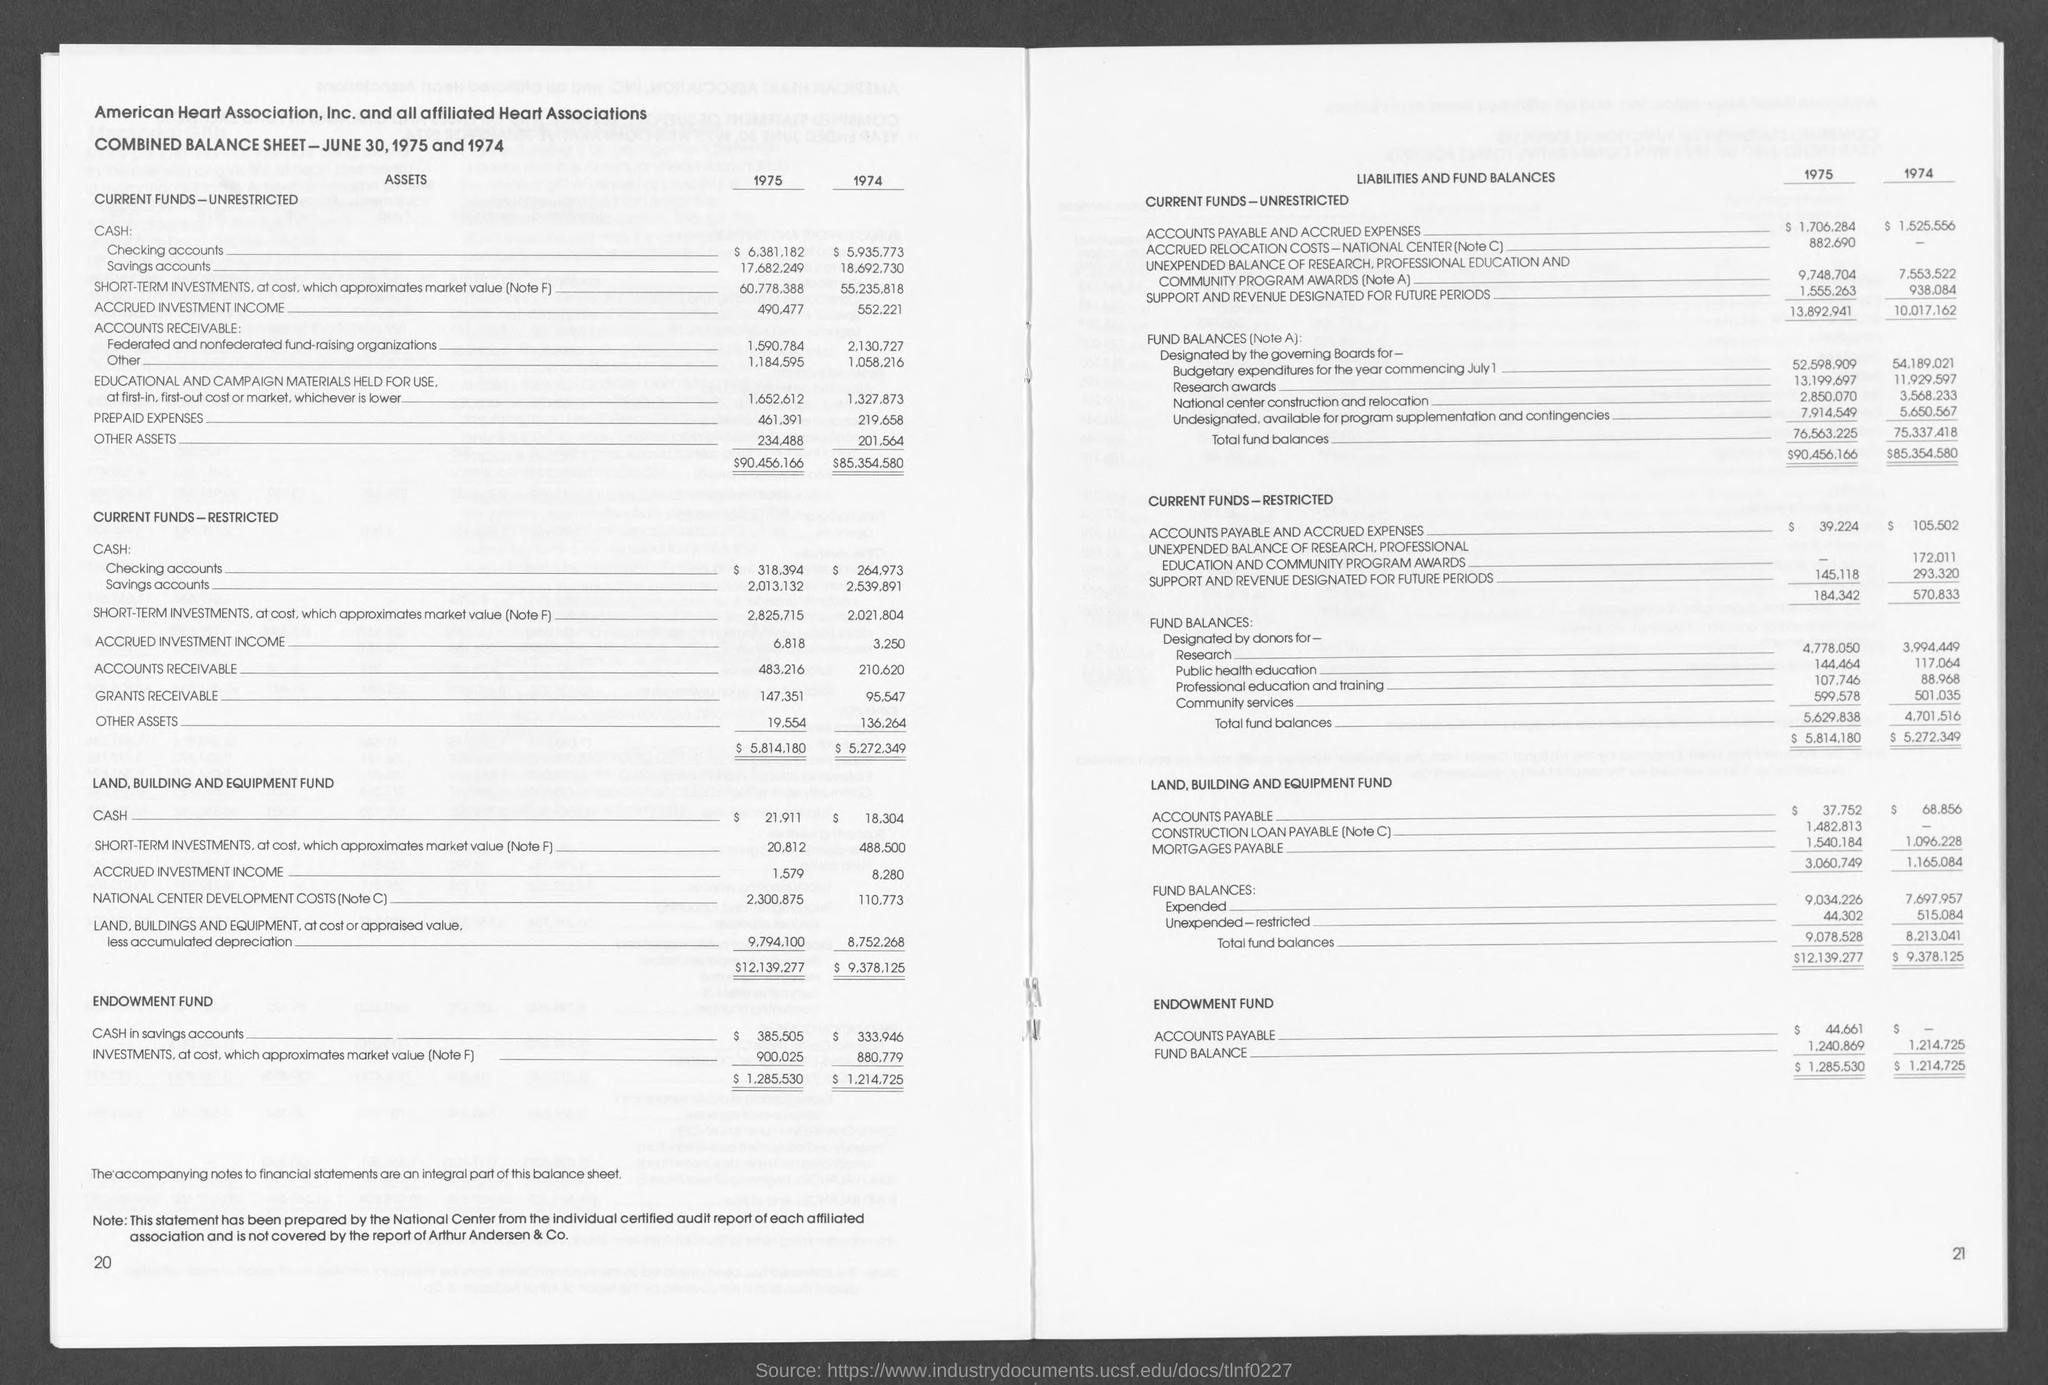What is the number at bottom- right corner of the page ?
Offer a very short reply. 21. What is the number at bottom-left corner of the page ?
Provide a succinct answer. 20. 